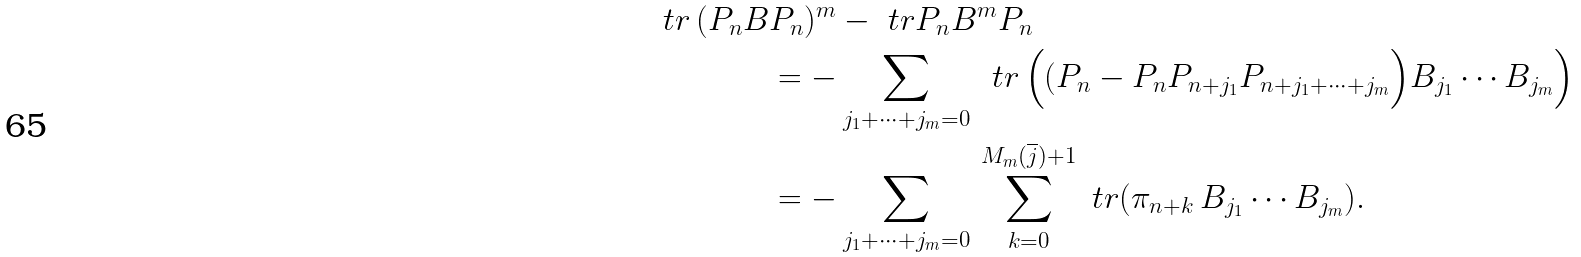<formula> <loc_0><loc_0><loc_500><loc_500>\ t r \, ( P _ { n } B & P _ { n } ) ^ { m } - \ t r P _ { n } B ^ { m } P _ { n } \\ & = - \sum _ { j _ { 1 } + \cdots + j _ { m } = 0 } \, \ t r \, \Big ( ( P _ { n } - P _ { n } P _ { n + j _ { 1 } } P _ { n + j _ { 1 } + \cdots + j _ { m } } \Big ) B _ { j _ { 1 } } \cdots B _ { j _ { m } } \Big ) \\ & = - \sum _ { j _ { 1 } + \cdots + j _ { m } = 0 } \, \sum _ { k = 0 } ^ { M _ { m } ( { \overline { j } } ) + 1 } \ t r ( \pi _ { n + k } \, B _ { j _ { 1 } } \cdots B _ { j _ { m } } ) .</formula> 